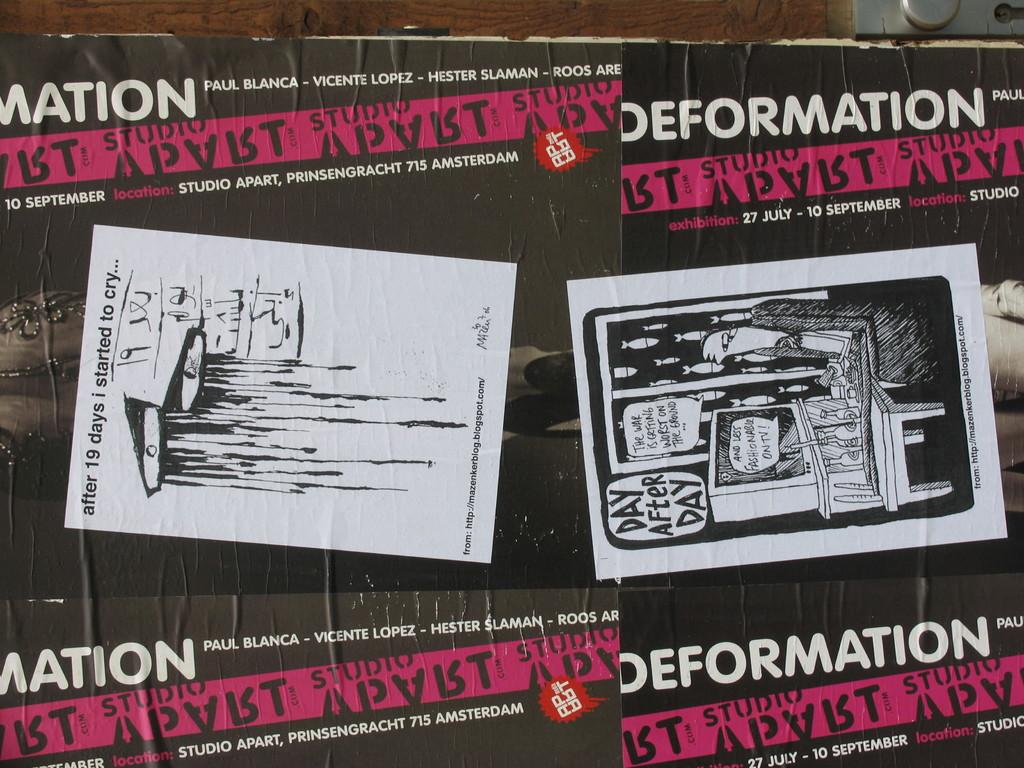<image>
Provide a brief description of the given image. ads from a music show the band is deformation 